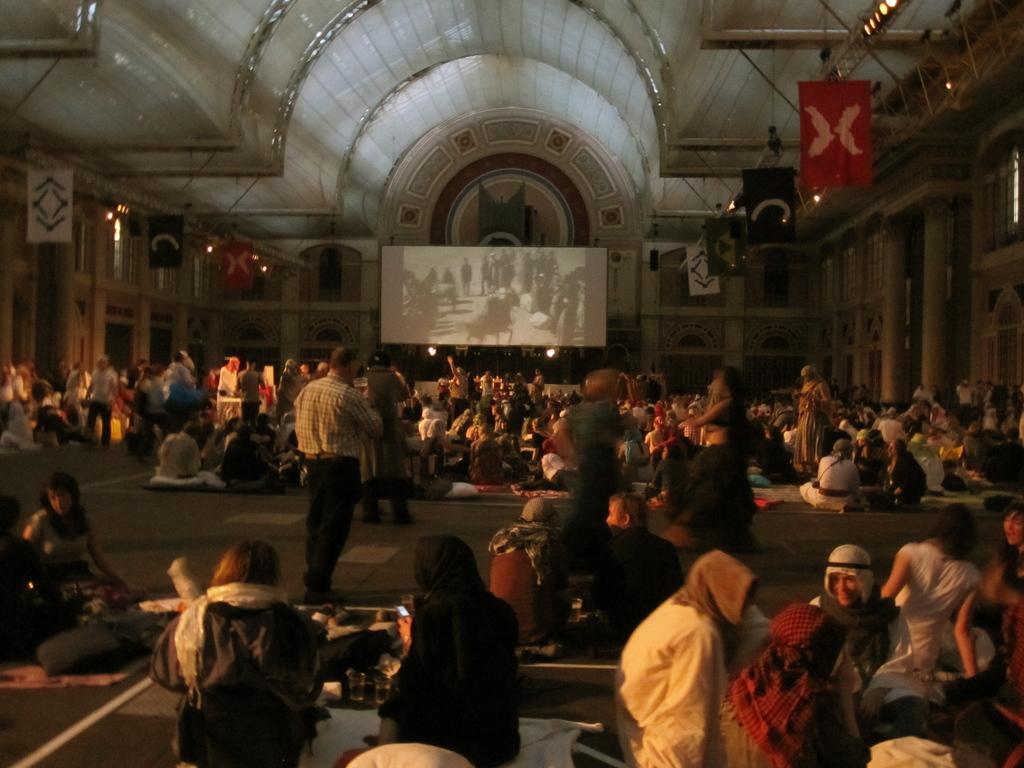How would you summarize this image in a sentence or two? Here some people are standing and some are sitting, this is a building. 